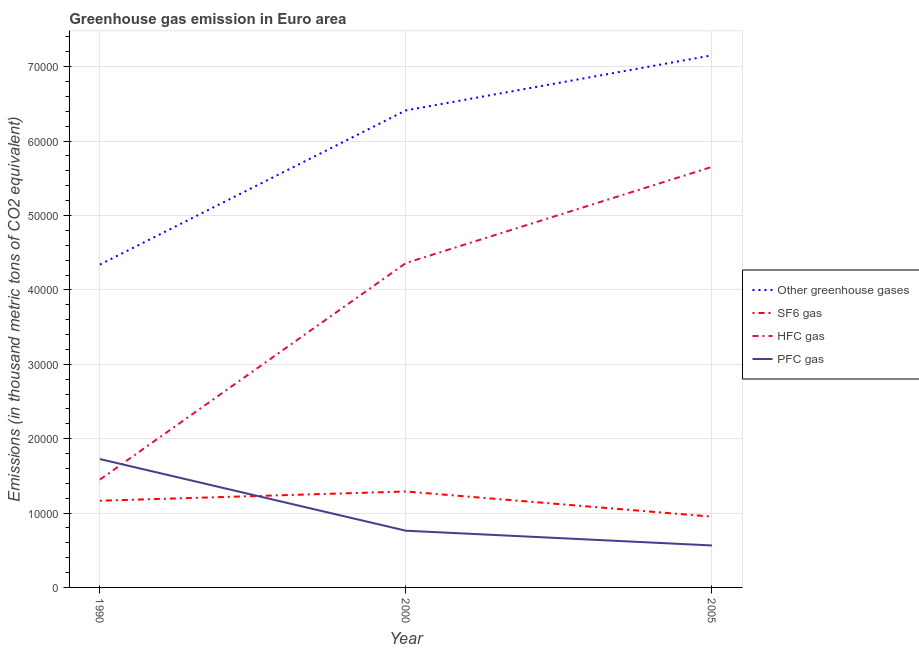Does the line corresponding to emission of sf6 gas intersect with the line corresponding to emission of greenhouse gases?
Provide a short and direct response. No. What is the emission of greenhouse gases in 2000?
Offer a very short reply. 6.41e+04. Across all years, what is the maximum emission of hfc gas?
Offer a very short reply. 5.65e+04. Across all years, what is the minimum emission of sf6 gas?
Your answer should be very brief. 9513.72. In which year was the emission of hfc gas maximum?
Make the answer very short. 2005. In which year was the emission of hfc gas minimum?
Provide a short and direct response. 1990. What is the total emission of hfc gas in the graph?
Offer a very short reply. 1.15e+05. What is the difference between the emission of sf6 gas in 2000 and that in 2005?
Offer a very short reply. 3383.48. What is the difference between the emission of pfc gas in 2000 and the emission of hfc gas in 1990?
Keep it short and to the point. -6866.6. What is the average emission of pfc gas per year?
Offer a terse response. 1.02e+04. In the year 2000, what is the difference between the emission of hfc gas and emission of greenhouse gases?
Provide a succinct answer. -2.05e+04. In how many years, is the emission of pfc gas greater than 66000 thousand metric tons?
Offer a very short reply. 0. What is the ratio of the emission of pfc gas in 2000 to that in 2005?
Keep it short and to the point. 1.35. Is the difference between the emission of sf6 gas in 2000 and 2005 greater than the difference between the emission of hfc gas in 2000 and 2005?
Keep it short and to the point. Yes. What is the difference between the highest and the second highest emission of sf6 gas?
Your answer should be very brief. 1242.6. What is the difference between the highest and the lowest emission of sf6 gas?
Your answer should be very brief. 3383.48. In how many years, is the emission of sf6 gas greater than the average emission of sf6 gas taken over all years?
Your answer should be very brief. 2. Is it the case that in every year, the sum of the emission of hfc gas and emission of greenhouse gases is greater than the sum of emission of pfc gas and emission of sf6 gas?
Your answer should be very brief. No. Is it the case that in every year, the sum of the emission of greenhouse gases and emission of sf6 gas is greater than the emission of hfc gas?
Provide a short and direct response. Yes. Is the emission of pfc gas strictly greater than the emission of hfc gas over the years?
Offer a very short reply. No. How many years are there in the graph?
Provide a succinct answer. 3. What is the difference between two consecutive major ticks on the Y-axis?
Make the answer very short. 10000. Are the values on the major ticks of Y-axis written in scientific E-notation?
Keep it short and to the point. No. Does the graph contain any zero values?
Your answer should be very brief. No. Does the graph contain grids?
Keep it short and to the point. Yes. What is the title of the graph?
Provide a short and direct response. Greenhouse gas emission in Euro area. What is the label or title of the Y-axis?
Provide a short and direct response. Emissions (in thousand metric tons of CO2 equivalent). What is the Emissions (in thousand metric tons of CO2 equivalent) in Other greenhouse gases in 1990?
Keep it short and to the point. 4.34e+04. What is the Emissions (in thousand metric tons of CO2 equivalent) of SF6 gas in 1990?
Provide a short and direct response. 1.17e+04. What is the Emissions (in thousand metric tons of CO2 equivalent) in HFC gas in 1990?
Provide a short and direct response. 1.45e+04. What is the Emissions (in thousand metric tons of CO2 equivalent) in PFC gas in 1990?
Your answer should be compact. 1.73e+04. What is the Emissions (in thousand metric tons of CO2 equivalent) in Other greenhouse gases in 2000?
Your answer should be compact. 6.41e+04. What is the Emissions (in thousand metric tons of CO2 equivalent) of SF6 gas in 2000?
Keep it short and to the point. 1.29e+04. What is the Emissions (in thousand metric tons of CO2 equivalent) of HFC gas in 2000?
Your response must be concise. 4.36e+04. What is the Emissions (in thousand metric tons of CO2 equivalent) of PFC gas in 2000?
Provide a short and direct response. 7625. What is the Emissions (in thousand metric tons of CO2 equivalent) in Other greenhouse gases in 2005?
Give a very brief answer. 7.15e+04. What is the Emissions (in thousand metric tons of CO2 equivalent) in SF6 gas in 2005?
Make the answer very short. 9513.72. What is the Emissions (in thousand metric tons of CO2 equivalent) in HFC gas in 2005?
Provide a short and direct response. 5.65e+04. What is the Emissions (in thousand metric tons of CO2 equivalent) in PFC gas in 2005?
Your answer should be very brief. 5640.06. Across all years, what is the maximum Emissions (in thousand metric tons of CO2 equivalent) of Other greenhouse gases?
Your response must be concise. 7.15e+04. Across all years, what is the maximum Emissions (in thousand metric tons of CO2 equivalent) in SF6 gas?
Keep it short and to the point. 1.29e+04. Across all years, what is the maximum Emissions (in thousand metric tons of CO2 equivalent) of HFC gas?
Give a very brief answer. 5.65e+04. Across all years, what is the maximum Emissions (in thousand metric tons of CO2 equivalent) in PFC gas?
Your answer should be compact. 1.73e+04. Across all years, what is the minimum Emissions (in thousand metric tons of CO2 equivalent) of Other greenhouse gases?
Offer a terse response. 4.34e+04. Across all years, what is the minimum Emissions (in thousand metric tons of CO2 equivalent) in SF6 gas?
Give a very brief answer. 9513.72. Across all years, what is the minimum Emissions (in thousand metric tons of CO2 equivalent) in HFC gas?
Your answer should be compact. 1.45e+04. Across all years, what is the minimum Emissions (in thousand metric tons of CO2 equivalent) in PFC gas?
Your response must be concise. 5640.06. What is the total Emissions (in thousand metric tons of CO2 equivalent) in Other greenhouse gases in the graph?
Keep it short and to the point. 1.79e+05. What is the total Emissions (in thousand metric tons of CO2 equivalent) in SF6 gas in the graph?
Offer a terse response. 3.41e+04. What is the total Emissions (in thousand metric tons of CO2 equivalent) of HFC gas in the graph?
Make the answer very short. 1.15e+05. What is the total Emissions (in thousand metric tons of CO2 equivalent) in PFC gas in the graph?
Your response must be concise. 3.05e+04. What is the difference between the Emissions (in thousand metric tons of CO2 equivalent) of Other greenhouse gases in 1990 and that in 2000?
Keep it short and to the point. -2.07e+04. What is the difference between the Emissions (in thousand metric tons of CO2 equivalent) in SF6 gas in 1990 and that in 2000?
Your answer should be compact. -1242.6. What is the difference between the Emissions (in thousand metric tons of CO2 equivalent) in HFC gas in 1990 and that in 2000?
Keep it short and to the point. -2.91e+04. What is the difference between the Emissions (in thousand metric tons of CO2 equivalent) in PFC gas in 1990 and that in 2000?
Your response must be concise. 9630.1. What is the difference between the Emissions (in thousand metric tons of CO2 equivalent) of Other greenhouse gases in 1990 and that in 2005?
Offer a very short reply. -2.81e+04. What is the difference between the Emissions (in thousand metric tons of CO2 equivalent) of SF6 gas in 1990 and that in 2005?
Your response must be concise. 2140.88. What is the difference between the Emissions (in thousand metric tons of CO2 equivalent) in HFC gas in 1990 and that in 2005?
Provide a succinct answer. -4.20e+04. What is the difference between the Emissions (in thousand metric tons of CO2 equivalent) of PFC gas in 1990 and that in 2005?
Keep it short and to the point. 1.16e+04. What is the difference between the Emissions (in thousand metric tons of CO2 equivalent) of Other greenhouse gases in 2000 and that in 2005?
Offer a very short reply. -7401.3. What is the difference between the Emissions (in thousand metric tons of CO2 equivalent) in SF6 gas in 2000 and that in 2005?
Give a very brief answer. 3383.48. What is the difference between the Emissions (in thousand metric tons of CO2 equivalent) of HFC gas in 2000 and that in 2005?
Make the answer very short. -1.29e+04. What is the difference between the Emissions (in thousand metric tons of CO2 equivalent) in PFC gas in 2000 and that in 2005?
Your answer should be very brief. 1984.94. What is the difference between the Emissions (in thousand metric tons of CO2 equivalent) of Other greenhouse gases in 1990 and the Emissions (in thousand metric tons of CO2 equivalent) of SF6 gas in 2000?
Make the answer very short. 3.05e+04. What is the difference between the Emissions (in thousand metric tons of CO2 equivalent) of Other greenhouse gases in 1990 and the Emissions (in thousand metric tons of CO2 equivalent) of HFC gas in 2000?
Your answer should be very brief. -206.3. What is the difference between the Emissions (in thousand metric tons of CO2 equivalent) of Other greenhouse gases in 1990 and the Emissions (in thousand metric tons of CO2 equivalent) of PFC gas in 2000?
Offer a terse response. 3.58e+04. What is the difference between the Emissions (in thousand metric tons of CO2 equivalent) of SF6 gas in 1990 and the Emissions (in thousand metric tons of CO2 equivalent) of HFC gas in 2000?
Keep it short and to the point. -3.20e+04. What is the difference between the Emissions (in thousand metric tons of CO2 equivalent) in SF6 gas in 1990 and the Emissions (in thousand metric tons of CO2 equivalent) in PFC gas in 2000?
Your response must be concise. 4029.6. What is the difference between the Emissions (in thousand metric tons of CO2 equivalent) of HFC gas in 1990 and the Emissions (in thousand metric tons of CO2 equivalent) of PFC gas in 2000?
Give a very brief answer. 6866.6. What is the difference between the Emissions (in thousand metric tons of CO2 equivalent) in Other greenhouse gases in 1990 and the Emissions (in thousand metric tons of CO2 equivalent) in SF6 gas in 2005?
Your answer should be very brief. 3.39e+04. What is the difference between the Emissions (in thousand metric tons of CO2 equivalent) of Other greenhouse gases in 1990 and the Emissions (in thousand metric tons of CO2 equivalent) of HFC gas in 2005?
Your answer should be compact. -1.31e+04. What is the difference between the Emissions (in thousand metric tons of CO2 equivalent) in Other greenhouse gases in 1990 and the Emissions (in thousand metric tons of CO2 equivalent) in PFC gas in 2005?
Make the answer very short. 3.78e+04. What is the difference between the Emissions (in thousand metric tons of CO2 equivalent) in SF6 gas in 1990 and the Emissions (in thousand metric tons of CO2 equivalent) in HFC gas in 2005?
Give a very brief answer. -4.49e+04. What is the difference between the Emissions (in thousand metric tons of CO2 equivalent) of SF6 gas in 1990 and the Emissions (in thousand metric tons of CO2 equivalent) of PFC gas in 2005?
Provide a succinct answer. 6014.54. What is the difference between the Emissions (in thousand metric tons of CO2 equivalent) of HFC gas in 1990 and the Emissions (in thousand metric tons of CO2 equivalent) of PFC gas in 2005?
Your response must be concise. 8851.54. What is the difference between the Emissions (in thousand metric tons of CO2 equivalent) of Other greenhouse gases in 2000 and the Emissions (in thousand metric tons of CO2 equivalent) of SF6 gas in 2005?
Provide a short and direct response. 5.46e+04. What is the difference between the Emissions (in thousand metric tons of CO2 equivalent) in Other greenhouse gases in 2000 and the Emissions (in thousand metric tons of CO2 equivalent) in HFC gas in 2005?
Ensure brevity in your answer.  7598.1. What is the difference between the Emissions (in thousand metric tons of CO2 equivalent) in Other greenhouse gases in 2000 and the Emissions (in thousand metric tons of CO2 equivalent) in PFC gas in 2005?
Your response must be concise. 5.85e+04. What is the difference between the Emissions (in thousand metric tons of CO2 equivalent) of SF6 gas in 2000 and the Emissions (in thousand metric tons of CO2 equivalent) of HFC gas in 2005?
Give a very brief answer. -4.36e+04. What is the difference between the Emissions (in thousand metric tons of CO2 equivalent) of SF6 gas in 2000 and the Emissions (in thousand metric tons of CO2 equivalent) of PFC gas in 2005?
Your answer should be very brief. 7257.14. What is the difference between the Emissions (in thousand metric tons of CO2 equivalent) of HFC gas in 2000 and the Emissions (in thousand metric tons of CO2 equivalent) of PFC gas in 2005?
Make the answer very short. 3.80e+04. What is the average Emissions (in thousand metric tons of CO2 equivalent) in Other greenhouse gases per year?
Your answer should be compact. 5.97e+04. What is the average Emissions (in thousand metric tons of CO2 equivalent) of SF6 gas per year?
Ensure brevity in your answer.  1.14e+04. What is the average Emissions (in thousand metric tons of CO2 equivalent) in HFC gas per year?
Offer a very short reply. 3.82e+04. What is the average Emissions (in thousand metric tons of CO2 equivalent) in PFC gas per year?
Your answer should be compact. 1.02e+04. In the year 1990, what is the difference between the Emissions (in thousand metric tons of CO2 equivalent) in Other greenhouse gases and Emissions (in thousand metric tons of CO2 equivalent) in SF6 gas?
Give a very brief answer. 3.17e+04. In the year 1990, what is the difference between the Emissions (in thousand metric tons of CO2 equivalent) in Other greenhouse gases and Emissions (in thousand metric tons of CO2 equivalent) in HFC gas?
Your answer should be very brief. 2.89e+04. In the year 1990, what is the difference between the Emissions (in thousand metric tons of CO2 equivalent) of Other greenhouse gases and Emissions (in thousand metric tons of CO2 equivalent) of PFC gas?
Offer a very short reply. 2.61e+04. In the year 1990, what is the difference between the Emissions (in thousand metric tons of CO2 equivalent) of SF6 gas and Emissions (in thousand metric tons of CO2 equivalent) of HFC gas?
Give a very brief answer. -2837. In the year 1990, what is the difference between the Emissions (in thousand metric tons of CO2 equivalent) in SF6 gas and Emissions (in thousand metric tons of CO2 equivalent) in PFC gas?
Make the answer very short. -5600.5. In the year 1990, what is the difference between the Emissions (in thousand metric tons of CO2 equivalent) in HFC gas and Emissions (in thousand metric tons of CO2 equivalent) in PFC gas?
Keep it short and to the point. -2763.5. In the year 2000, what is the difference between the Emissions (in thousand metric tons of CO2 equivalent) in Other greenhouse gases and Emissions (in thousand metric tons of CO2 equivalent) in SF6 gas?
Provide a succinct answer. 5.12e+04. In the year 2000, what is the difference between the Emissions (in thousand metric tons of CO2 equivalent) of Other greenhouse gases and Emissions (in thousand metric tons of CO2 equivalent) of HFC gas?
Keep it short and to the point. 2.05e+04. In the year 2000, what is the difference between the Emissions (in thousand metric tons of CO2 equivalent) of Other greenhouse gases and Emissions (in thousand metric tons of CO2 equivalent) of PFC gas?
Your answer should be compact. 5.65e+04. In the year 2000, what is the difference between the Emissions (in thousand metric tons of CO2 equivalent) of SF6 gas and Emissions (in thousand metric tons of CO2 equivalent) of HFC gas?
Ensure brevity in your answer.  -3.07e+04. In the year 2000, what is the difference between the Emissions (in thousand metric tons of CO2 equivalent) of SF6 gas and Emissions (in thousand metric tons of CO2 equivalent) of PFC gas?
Your answer should be compact. 5272.2. In the year 2000, what is the difference between the Emissions (in thousand metric tons of CO2 equivalent) in HFC gas and Emissions (in thousand metric tons of CO2 equivalent) in PFC gas?
Your response must be concise. 3.60e+04. In the year 2005, what is the difference between the Emissions (in thousand metric tons of CO2 equivalent) of Other greenhouse gases and Emissions (in thousand metric tons of CO2 equivalent) of SF6 gas?
Ensure brevity in your answer.  6.20e+04. In the year 2005, what is the difference between the Emissions (in thousand metric tons of CO2 equivalent) of Other greenhouse gases and Emissions (in thousand metric tons of CO2 equivalent) of HFC gas?
Provide a succinct answer. 1.50e+04. In the year 2005, what is the difference between the Emissions (in thousand metric tons of CO2 equivalent) in Other greenhouse gases and Emissions (in thousand metric tons of CO2 equivalent) in PFC gas?
Make the answer very short. 6.59e+04. In the year 2005, what is the difference between the Emissions (in thousand metric tons of CO2 equivalent) of SF6 gas and Emissions (in thousand metric tons of CO2 equivalent) of HFC gas?
Provide a short and direct response. -4.70e+04. In the year 2005, what is the difference between the Emissions (in thousand metric tons of CO2 equivalent) of SF6 gas and Emissions (in thousand metric tons of CO2 equivalent) of PFC gas?
Ensure brevity in your answer.  3873.66. In the year 2005, what is the difference between the Emissions (in thousand metric tons of CO2 equivalent) in HFC gas and Emissions (in thousand metric tons of CO2 equivalent) in PFC gas?
Offer a terse response. 5.09e+04. What is the ratio of the Emissions (in thousand metric tons of CO2 equivalent) in Other greenhouse gases in 1990 to that in 2000?
Provide a succinct answer. 0.68. What is the ratio of the Emissions (in thousand metric tons of CO2 equivalent) of SF6 gas in 1990 to that in 2000?
Your answer should be compact. 0.9. What is the ratio of the Emissions (in thousand metric tons of CO2 equivalent) in HFC gas in 1990 to that in 2000?
Your response must be concise. 0.33. What is the ratio of the Emissions (in thousand metric tons of CO2 equivalent) of PFC gas in 1990 to that in 2000?
Give a very brief answer. 2.26. What is the ratio of the Emissions (in thousand metric tons of CO2 equivalent) in Other greenhouse gases in 1990 to that in 2005?
Give a very brief answer. 0.61. What is the ratio of the Emissions (in thousand metric tons of CO2 equivalent) in SF6 gas in 1990 to that in 2005?
Your answer should be very brief. 1.23. What is the ratio of the Emissions (in thousand metric tons of CO2 equivalent) in HFC gas in 1990 to that in 2005?
Provide a succinct answer. 0.26. What is the ratio of the Emissions (in thousand metric tons of CO2 equivalent) of PFC gas in 1990 to that in 2005?
Your answer should be very brief. 3.06. What is the ratio of the Emissions (in thousand metric tons of CO2 equivalent) of Other greenhouse gases in 2000 to that in 2005?
Give a very brief answer. 0.9. What is the ratio of the Emissions (in thousand metric tons of CO2 equivalent) of SF6 gas in 2000 to that in 2005?
Your answer should be very brief. 1.36. What is the ratio of the Emissions (in thousand metric tons of CO2 equivalent) of HFC gas in 2000 to that in 2005?
Provide a short and direct response. 0.77. What is the ratio of the Emissions (in thousand metric tons of CO2 equivalent) in PFC gas in 2000 to that in 2005?
Provide a succinct answer. 1.35. What is the difference between the highest and the second highest Emissions (in thousand metric tons of CO2 equivalent) of Other greenhouse gases?
Your answer should be very brief. 7401.3. What is the difference between the highest and the second highest Emissions (in thousand metric tons of CO2 equivalent) in SF6 gas?
Provide a succinct answer. 1242.6. What is the difference between the highest and the second highest Emissions (in thousand metric tons of CO2 equivalent) in HFC gas?
Provide a succinct answer. 1.29e+04. What is the difference between the highest and the second highest Emissions (in thousand metric tons of CO2 equivalent) of PFC gas?
Your answer should be compact. 9630.1. What is the difference between the highest and the lowest Emissions (in thousand metric tons of CO2 equivalent) in Other greenhouse gases?
Your answer should be compact. 2.81e+04. What is the difference between the highest and the lowest Emissions (in thousand metric tons of CO2 equivalent) in SF6 gas?
Your answer should be compact. 3383.48. What is the difference between the highest and the lowest Emissions (in thousand metric tons of CO2 equivalent) of HFC gas?
Your response must be concise. 4.20e+04. What is the difference between the highest and the lowest Emissions (in thousand metric tons of CO2 equivalent) of PFC gas?
Offer a terse response. 1.16e+04. 